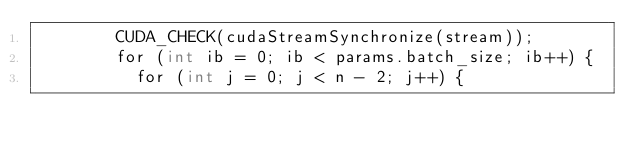Convert code to text. <code><loc_0><loc_0><loc_500><loc_500><_Cuda_>        CUDA_CHECK(cudaStreamSynchronize(stream));
        for (int ib = 0; ib < params.batch_size; ib++) {
          for (int j = 0; j < n - 2; j++) {</code> 